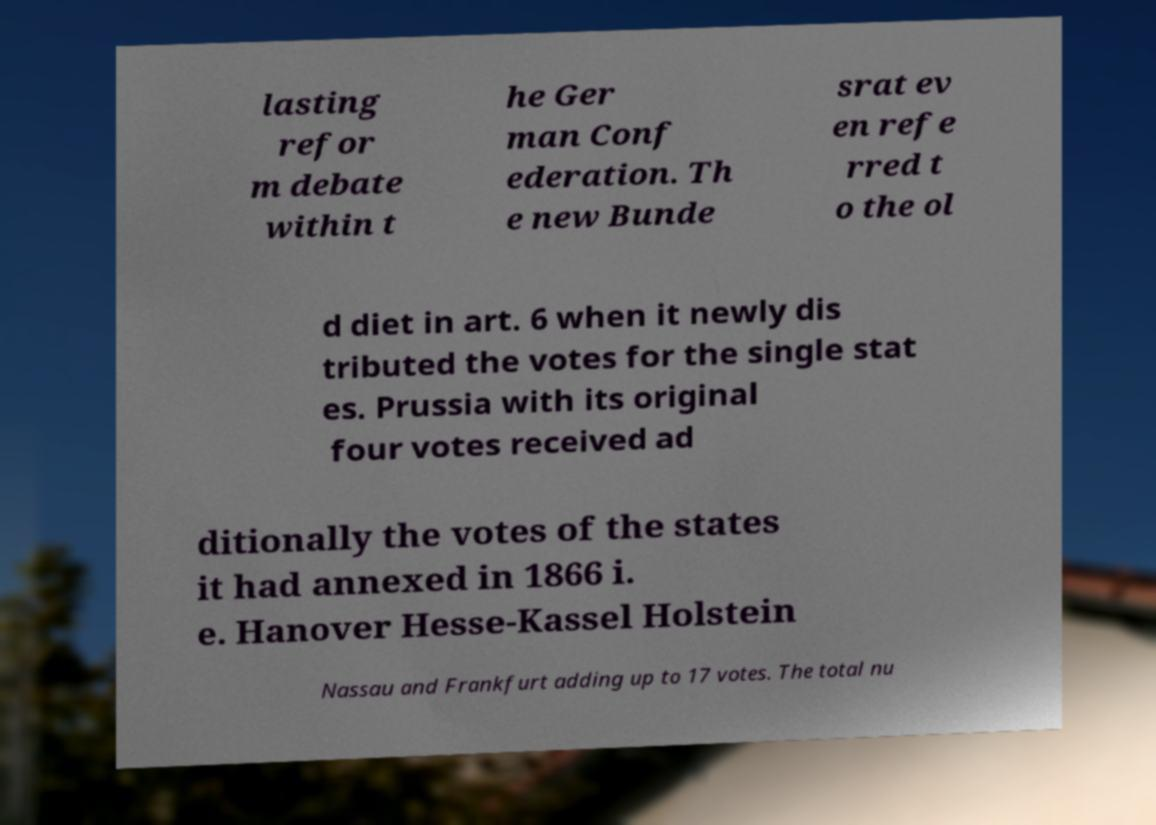What messages or text are displayed in this image? I need them in a readable, typed format. lasting refor m debate within t he Ger man Conf ederation. Th e new Bunde srat ev en refe rred t o the ol d diet in art. 6 when it newly dis tributed the votes for the single stat es. Prussia with its original four votes received ad ditionally the votes of the states it had annexed in 1866 i. e. Hanover Hesse-Kassel Holstein Nassau and Frankfurt adding up to 17 votes. The total nu 